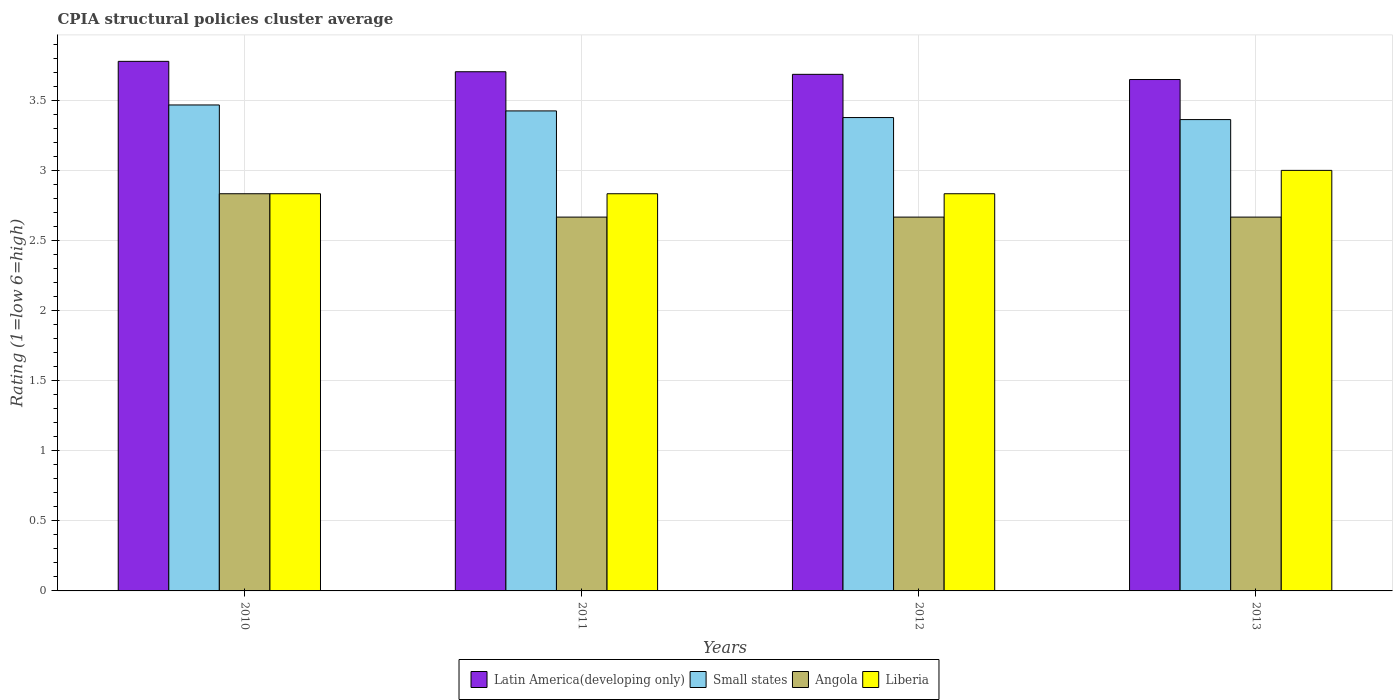How many different coloured bars are there?
Offer a terse response. 4. How many groups of bars are there?
Your response must be concise. 4. How many bars are there on the 1st tick from the left?
Offer a terse response. 4. What is the label of the 4th group of bars from the left?
Offer a terse response. 2013. What is the CPIA rating in Small states in 2010?
Keep it short and to the point. 3.47. Across all years, what is the maximum CPIA rating in Latin America(developing only)?
Your answer should be very brief. 3.78. Across all years, what is the minimum CPIA rating in Small states?
Ensure brevity in your answer.  3.36. In which year was the CPIA rating in Small states minimum?
Keep it short and to the point. 2013. What is the total CPIA rating in Small states in the graph?
Your response must be concise. 13.63. What is the difference between the CPIA rating in Angola in 2010 and the CPIA rating in Small states in 2013?
Offer a terse response. -0.53. What is the average CPIA rating in Liberia per year?
Make the answer very short. 2.87. In the year 2012, what is the difference between the CPIA rating in Liberia and CPIA rating in Angola?
Offer a very short reply. 0.17. What is the difference between the highest and the second highest CPIA rating in Liberia?
Your response must be concise. 0.17. What is the difference between the highest and the lowest CPIA rating in Angola?
Offer a terse response. 0.17. In how many years, is the CPIA rating in Latin America(developing only) greater than the average CPIA rating in Latin America(developing only) taken over all years?
Provide a short and direct response. 1. Is the sum of the CPIA rating in Latin America(developing only) in 2012 and 2013 greater than the maximum CPIA rating in Liberia across all years?
Keep it short and to the point. Yes. Is it the case that in every year, the sum of the CPIA rating in Small states and CPIA rating in Latin America(developing only) is greater than the sum of CPIA rating in Liberia and CPIA rating in Angola?
Your response must be concise. Yes. What does the 2nd bar from the left in 2011 represents?
Your answer should be compact. Small states. What does the 3rd bar from the right in 2011 represents?
Your response must be concise. Small states. How many bars are there?
Your answer should be very brief. 16. Are all the bars in the graph horizontal?
Give a very brief answer. No. How many years are there in the graph?
Ensure brevity in your answer.  4. Does the graph contain any zero values?
Keep it short and to the point. No. Where does the legend appear in the graph?
Your answer should be compact. Bottom center. What is the title of the graph?
Make the answer very short. CPIA structural policies cluster average. Does "Kiribati" appear as one of the legend labels in the graph?
Offer a terse response. No. What is the label or title of the Y-axis?
Offer a terse response. Rating (1=low 6=high). What is the Rating (1=low 6=high) of Latin America(developing only) in 2010?
Offer a terse response. 3.78. What is the Rating (1=low 6=high) in Small states in 2010?
Give a very brief answer. 3.47. What is the Rating (1=low 6=high) of Angola in 2010?
Offer a terse response. 2.83. What is the Rating (1=low 6=high) in Liberia in 2010?
Make the answer very short. 2.83. What is the Rating (1=low 6=high) of Latin America(developing only) in 2011?
Offer a very short reply. 3.7. What is the Rating (1=low 6=high) of Small states in 2011?
Provide a succinct answer. 3.42. What is the Rating (1=low 6=high) of Angola in 2011?
Give a very brief answer. 2.67. What is the Rating (1=low 6=high) in Liberia in 2011?
Provide a short and direct response. 2.83. What is the Rating (1=low 6=high) in Latin America(developing only) in 2012?
Ensure brevity in your answer.  3.69. What is the Rating (1=low 6=high) in Small states in 2012?
Provide a short and direct response. 3.38. What is the Rating (1=low 6=high) of Angola in 2012?
Provide a succinct answer. 2.67. What is the Rating (1=low 6=high) of Liberia in 2012?
Make the answer very short. 2.83. What is the Rating (1=low 6=high) in Latin America(developing only) in 2013?
Provide a short and direct response. 3.65. What is the Rating (1=low 6=high) of Small states in 2013?
Offer a terse response. 3.36. What is the Rating (1=low 6=high) of Angola in 2013?
Give a very brief answer. 2.67. What is the Rating (1=low 6=high) in Liberia in 2013?
Ensure brevity in your answer.  3. Across all years, what is the maximum Rating (1=low 6=high) of Latin America(developing only)?
Provide a short and direct response. 3.78. Across all years, what is the maximum Rating (1=low 6=high) in Small states?
Provide a succinct answer. 3.47. Across all years, what is the maximum Rating (1=low 6=high) of Angola?
Make the answer very short. 2.83. Across all years, what is the minimum Rating (1=low 6=high) in Latin America(developing only)?
Ensure brevity in your answer.  3.65. Across all years, what is the minimum Rating (1=low 6=high) in Small states?
Offer a terse response. 3.36. Across all years, what is the minimum Rating (1=low 6=high) in Angola?
Offer a very short reply. 2.67. Across all years, what is the minimum Rating (1=low 6=high) in Liberia?
Give a very brief answer. 2.83. What is the total Rating (1=low 6=high) in Latin America(developing only) in the graph?
Keep it short and to the point. 14.81. What is the total Rating (1=low 6=high) of Small states in the graph?
Make the answer very short. 13.63. What is the total Rating (1=low 6=high) of Angola in the graph?
Keep it short and to the point. 10.83. What is the total Rating (1=low 6=high) in Liberia in the graph?
Give a very brief answer. 11.5. What is the difference between the Rating (1=low 6=high) in Latin America(developing only) in 2010 and that in 2011?
Offer a very short reply. 0.07. What is the difference between the Rating (1=low 6=high) of Small states in 2010 and that in 2011?
Offer a terse response. 0.04. What is the difference between the Rating (1=low 6=high) in Angola in 2010 and that in 2011?
Give a very brief answer. 0.17. What is the difference between the Rating (1=low 6=high) in Liberia in 2010 and that in 2011?
Ensure brevity in your answer.  0. What is the difference between the Rating (1=low 6=high) in Latin America(developing only) in 2010 and that in 2012?
Your answer should be compact. 0.09. What is the difference between the Rating (1=low 6=high) of Small states in 2010 and that in 2012?
Give a very brief answer. 0.09. What is the difference between the Rating (1=low 6=high) in Angola in 2010 and that in 2012?
Provide a short and direct response. 0.17. What is the difference between the Rating (1=low 6=high) in Liberia in 2010 and that in 2012?
Give a very brief answer. 0. What is the difference between the Rating (1=low 6=high) in Latin America(developing only) in 2010 and that in 2013?
Provide a short and direct response. 0.13. What is the difference between the Rating (1=low 6=high) of Small states in 2010 and that in 2013?
Provide a short and direct response. 0.1. What is the difference between the Rating (1=low 6=high) in Angola in 2010 and that in 2013?
Keep it short and to the point. 0.17. What is the difference between the Rating (1=low 6=high) in Latin America(developing only) in 2011 and that in 2012?
Give a very brief answer. 0.02. What is the difference between the Rating (1=low 6=high) of Small states in 2011 and that in 2012?
Ensure brevity in your answer.  0.05. What is the difference between the Rating (1=low 6=high) in Angola in 2011 and that in 2012?
Keep it short and to the point. 0. What is the difference between the Rating (1=low 6=high) of Latin America(developing only) in 2011 and that in 2013?
Your answer should be very brief. 0.06. What is the difference between the Rating (1=low 6=high) of Small states in 2011 and that in 2013?
Make the answer very short. 0.06. What is the difference between the Rating (1=low 6=high) in Liberia in 2011 and that in 2013?
Your answer should be compact. -0.17. What is the difference between the Rating (1=low 6=high) of Latin America(developing only) in 2012 and that in 2013?
Provide a short and direct response. 0.04. What is the difference between the Rating (1=low 6=high) of Small states in 2012 and that in 2013?
Ensure brevity in your answer.  0.01. What is the difference between the Rating (1=low 6=high) of Latin America(developing only) in 2010 and the Rating (1=low 6=high) of Small states in 2011?
Provide a succinct answer. 0.35. What is the difference between the Rating (1=low 6=high) in Small states in 2010 and the Rating (1=low 6=high) in Liberia in 2011?
Your answer should be compact. 0.63. What is the difference between the Rating (1=low 6=high) of Angola in 2010 and the Rating (1=low 6=high) of Liberia in 2011?
Offer a very short reply. 0. What is the difference between the Rating (1=low 6=high) of Latin America(developing only) in 2010 and the Rating (1=low 6=high) of Small states in 2012?
Your answer should be very brief. 0.4. What is the difference between the Rating (1=low 6=high) in Latin America(developing only) in 2010 and the Rating (1=low 6=high) in Angola in 2012?
Offer a terse response. 1.11. What is the difference between the Rating (1=low 6=high) in Latin America(developing only) in 2010 and the Rating (1=low 6=high) in Liberia in 2012?
Offer a very short reply. 0.94. What is the difference between the Rating (1=low 6=high) in Small states in 2010 and the Rating (1=low 6=high) in Angola in 2012?
Keep it short and to the point. 0.8. What is the difference between the Rating (1=low 6=high) of Small states in 2010 and the Rating (1=low 6=high) of Liberia in 2012?
Provide a succinct answer. 0.63. What is the difference between the Rating (1=low 6=high) in Latin America(developing only) in 2010 and the Rating (1=low 6=high) in Small states in 2013?
Provide a succinct answer. 0.42. What is the difference between the Rating (1=low 6=high) of Small states in 2010 and the Rating (1=low 6=high) of Liberia in 2013?
Make the answer very short. 0.47. What is the difference between the Rating (1=low 6=high) in Latin America(developing only) in 2011 and the Rating (1=low 6=high) in Small states in 2012?
Keep it short and to the point. 0.33. What is the difference between the Rating (1=low 6=high) in Latin America(developing only) in 2011 and the Rating (1=low 6=high) in Liberia in 2012?
Your answer should be compact. 0.87. What is the difference between the Rating (1=low 6=high) in Small states in 2011 and the Rating (1=low 6=high) in Angola in 2012?
Your answer should be compact. 0.76. What is the difference between the Rating (1=low 6=high) in Small states in 2011 and the Rating (1=low 6=high) in Liberia in 2012?
Your answer should be very brief. 0.59. What is the difference between the Rating (1=low 6=high) in Angola in 2011 and the Rating (1=low 6=high) in Liberia in 2012?
Give a very brief answer. -0.17. What is the difference between the Rating (1=low 6=high) in Latin America(developing only) in 2011 and the Rating (1=low 6=high) in Small states in 2013?
Your answer should be compact. 0.34. What is the difference between the Rating (1=low 6=high) in Latin America(developing only) in 2011 and the Rating (1=low 6=high) in Angola in 2013?
Ensure brevity in your answer.  1.04. What is the difference between the Rating (1=low 6=high) of Latin America(developing only) in 2011 and the Rating (1=low 6=high) of Liberia in 2013?
Provide a short and direct response. 0.7. What is the difference between the Rating (1=low 6=high) of Small states in 2011 and the Rating (1=low 6=high) of Angola in 2013?
Make the answer very short. 0.76. What is the difference between the Rating (1=low 6=high) in Small states in 2011 and the Rating (1=low 6=high) in Liberia in 2013?
Provide a succinct answer. 0.42. What is the difference between the Rating (1=low 6=high) of Angola in 2011 and the Rating (1=low 6=high) of Liberia in 2013?
Your answer should be compact. -0.33. What is the difference between the Rating (1=low 6=high) of Latin America(developing only) in 2012 and the Rating (1=low 6=high) of Small states in 2013?
Your answer should be very brief. 0.32. What is the difference between the Rating (1=low 6=high) in Latin America(developing only) in 2012 and the Rating (1=low 6=high) in Angola in 2013?
Keep it short and to the point. 1.02. What is the difference between the Rating (1=low 6=high) in Latin America(developing only) in 2012 and the Rating (1=low 6=high) in Liberia in 2013?
Make the answer very short. 0.69. What is the difference between the Rating (1=low 6=high) of Small states in 2012 and the Rating (1=low 6=high) of Angola in 2013?
Offer a terse response. 0.71. What is the difference between the Rating (1=low 6=high) of Small states in 2012 and the Rating (1=low 6=high) of Liberia in 2013?
Make the answer very short. 0.38. What is the average Rating (1=low 6=high) of Latin America(developing only) per year?
Your response must be concise. 3.7. What is the average Rating (1=low 6=high) of Small states per year?
Provide a succinct answer. 3.41. What is the average Rating (1=low 6=high) of Angola per year?
Make the answer very short. 2.71. What is the average Rating (1=low 6=high) in Liberia per year?
Make the answer very short. 2.88. In the year 2010, what is the difference between the Rating (1=low 6=high) in Latin America(developing only) and Rating (1=low 6=high) in Small states?
Make the answer very short. 0.31. In the year 2010, what is the difference between the Rating (1=low 6=high) of Small states and Rating (1=low 6=high) of Angola?
Keep it short and to the point. 0.63. In the year 2010, what is the difference between the Rating (1=low 6=high) of Small states and Rating (1=low 6=high) of Liberia?
Ensure brevity in your answer.  0.63. In the year 2010, what is the difference between the Rating (1=low 6=high) in Angola and Rating (1=low 6=high) in Liberia?
Offer a very short reply. 0. In the year 2011, what is the difference between the Rating (1=low 6=high) in Latin America(developing only) and Rating (1=low 6=high) in Small states?
Your answer should be compact. 0.28. In the year 2011, what is the difference between the Rating (1=low 6=high) of Latin America(developing only) and Rating (1=low 6=high) of Liberia?
Make the answer very short. 0.87. In the year 2011, what is the difference between the Rating (1=low 6=high) of Small states and Rating (1=low 6=high) of Angola?
Your answer should be compact. 0.76. In the year 2011, what is the difference between the Rating (1=low 6=high) of Small states and Rating (1=low 6=high) of Liberia?
Make the answer very short. 0.59. In the year 2011, what is the difference between the Rating (1=low 6=high) of Angola and Rating (1=low 6=high) of Liberia?
Keep it short and to the point. -0.17. In the year 2012, what is the difference between the Rating (1=low 6=high) of Latin America(developing only) and Rating (1=low 6=high) of Small states?
Make the answer very short. 0.31. In the year 2012, what is the difference between the Rating (1=low 6=high) of Latin America(developing only) and Rating (1=low 6=high) of Angola?
Make the answer very short. 1.02. In the year 2012, what is the difference between the Rating (1=low 6=high) in Latin America(developing only) and Rating (1=low 6=high) in Liberia?
Provide a short and direct response. 0.85. In the year 2012, what is the difference between the Rating (1=low 6=high) in Small states and Rating (1=low 6=high) in Angola?
Your answer should be compact. 0.71. In the year 2012, what is the difference between the Rating (1=low 6=high) in Small states and Rating (1=low 6=high) in Liberia?
Your response must be concise. 0.54. In the year 2013, what is the difference between the Rating (1=low 6=high) of Latin America(developing only) and Rating (1=low 6=high) of Small states?
Provide a succinct answer. 0.29. In the year 2013, what is the difference between the Rating (1=low 6=high) of Latin America(developing only) and Rating (1=low 6=high) of Angola?
Keep it short and to the point. 0.98. In the year 2013, what is the difference between the Rating (1=low 6=high) in Latin America(developing only) and Rating (1=low 6=high) in Liberia?
Your answer should be very brief. 0.65. In the year 2013, what is the difference between the Rating (1=low 6=high) of Small states and Rating (1=low 6=high) of Angola?
Your answer should be compact. 0.7. In the year 2013, what is the difference between the Rating (1=low 6=high) of Small states and Rating (1=low 6=high) of Liberia?
Your response must be concise. 0.36. In the year 2013, what is the difference between the Rating (1=low 6=high) in Angola and Rating (1=low 6=high) in Liberia?
Make the answer very short. -0.33. What is the ratio of the Rating (1=low 6=high) of Latin America(developing only) in 2010 to that in 2011?
Your answer should be very brief. 1.02. What is the ratio of the Rating (1=low 6=high) of Small states in 2010 to that in 2011?
Give a very brief answer. 1.01. What is the ratio of the Rating (1=low 6=high) in Angola in 2010 to that in 2011?
Your response must be concise. 1.06. What is the ratio of the Rating (1=low 6=high) in Latin America(developing only) in 2010 to that in 2012?
Keep it short and to the point. 1.03. What is the ratio of the Rating (1=low 6=high) of Small states in 2010 to that in 2012?
Ensure brevity in your answer.  1.03. What is the ratio of the Rating (1=low 6=high) in Liberia in 2010 to that in 2012?
Your answer should be very brief. 1. What is the ratio of the Rating (1=low 6=high) in Latin America(developing only) in 2010 to that in 2013?
Offer a very short reply. 1.04. What is the ratio of the Rating (1=low 6=high) in Small states in 2010 to that in 2013?
Ensure brevity in your answer.  1.03. What is the ratio of the Rating (1=low 6=high) in Liberia in 2010 to that in 2013?
Offer a very short reply. 0.94. What is the ratio of the Rating (1=low 6=high) in Small states in 2011 to that in 2012?
Your answer should be compact. 1.01. What is the ratio of the Rating (1=low 6=high) of Angola in 2011 to that in 2012?
Your answer should be compact. 1. What is the ratio of the Rating (1=low 6=high) in Latin America(developing only) in 2011 to that in 2013?
Offer a very short reply. 1.02. What is the ratio of the Rating (1=low 6=high) of Small states in 2011 to that in 2013?
Your answer should be very brief. 1.02. What is the ratio of the Rating (1=low 6=high) in Angola in 2011 to that in 2013?
Ensure brevity in your answer.  1. What is the ratio of the Rating (1=low 6=high) in Latin America(developing only) in 2012 to that in 2013?
Ensure brevity in your answer.  1.01. What is the ratio of the Rating (1=low 6=high) of Small states in 2012 to that in 2013?
Offer a terse response. 1. What is the ratio of the Rating (1=low 6=high) of Angola in 2012 to that in 2013?
Your answer should be compact. 1. What is the ratio of the Rating (1=low 6=high) of Liberia in 2012 to that in 2013?
Keep it short and to the point. 0.94. What is the difference between the highest and the second highest Rating (1=low 6=high) of Latin America(developing only)?
Provide a succinct answer. 0.07. What is the difference between the highest and the second highest Rating (1=low 6=high) in Small states?
Give a very brief answer. 0.04. What is the difference between the highest and the second highest Rating (1=low 6=high) in Angola?
Offer a very short reply. 0.17. What is the difference between the highest and the second highest Rating (1=low 6=high) of Liberia?
Provide a succinct answer. 0.17. What is the difference between the highest and the lowest Rating (1=low 6=high) of Latin America(developing only)?
Your answer should be very brief. 0.13. What is the difference between the highest and the lowest Rating (1=low 6=high) in Small states?
Your answer should be very brief. 0.1. What is the difference between the highest and the lowest Rating (1=low 6=high) of Liberia?
Offer a very short reply. 0.17. 